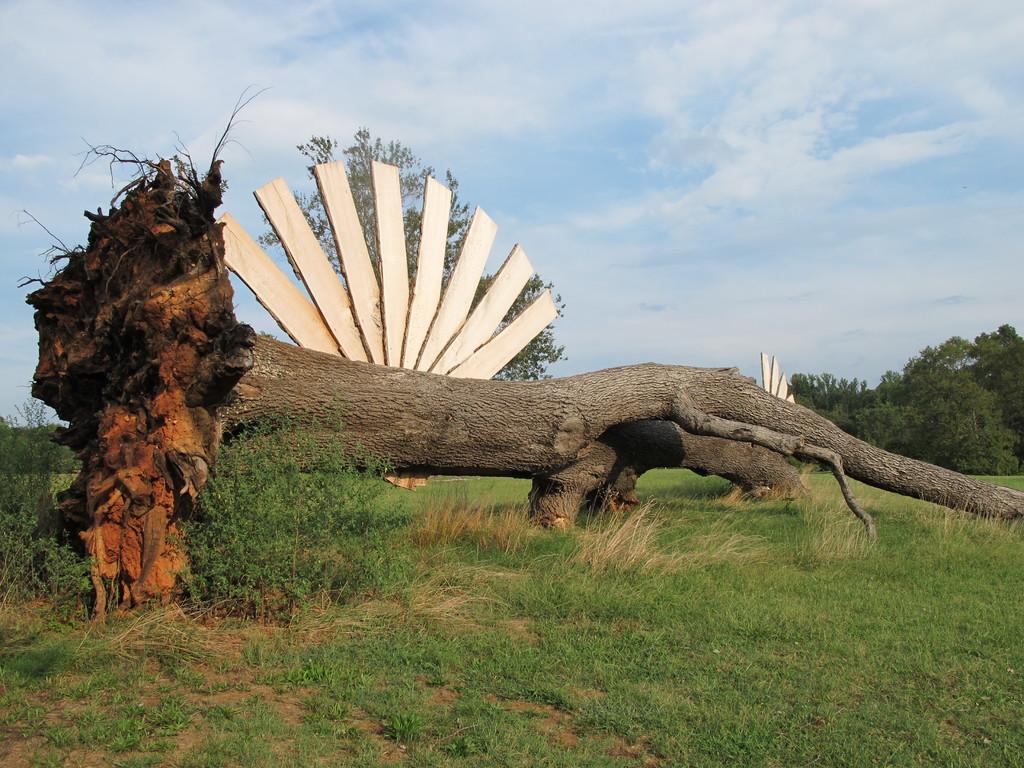Can you describe this image briefly? In this picture I can see tree trunk, plants, wooden sheets, grass, trees, and in the background there is sky. 